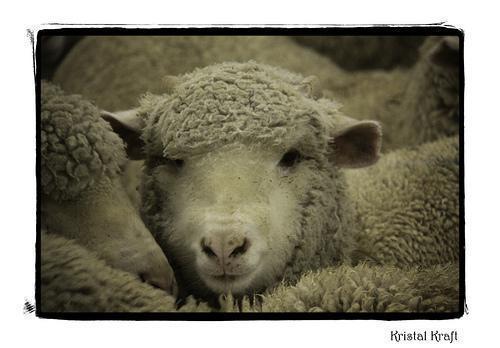What sound will he make?
Indicate the correct choice and explain in the format: 'Answer: answer
Rationale: rationale.'
Options: Meow, baa, woof, quack. Answer: baa.
Rationale: This is a sheep 